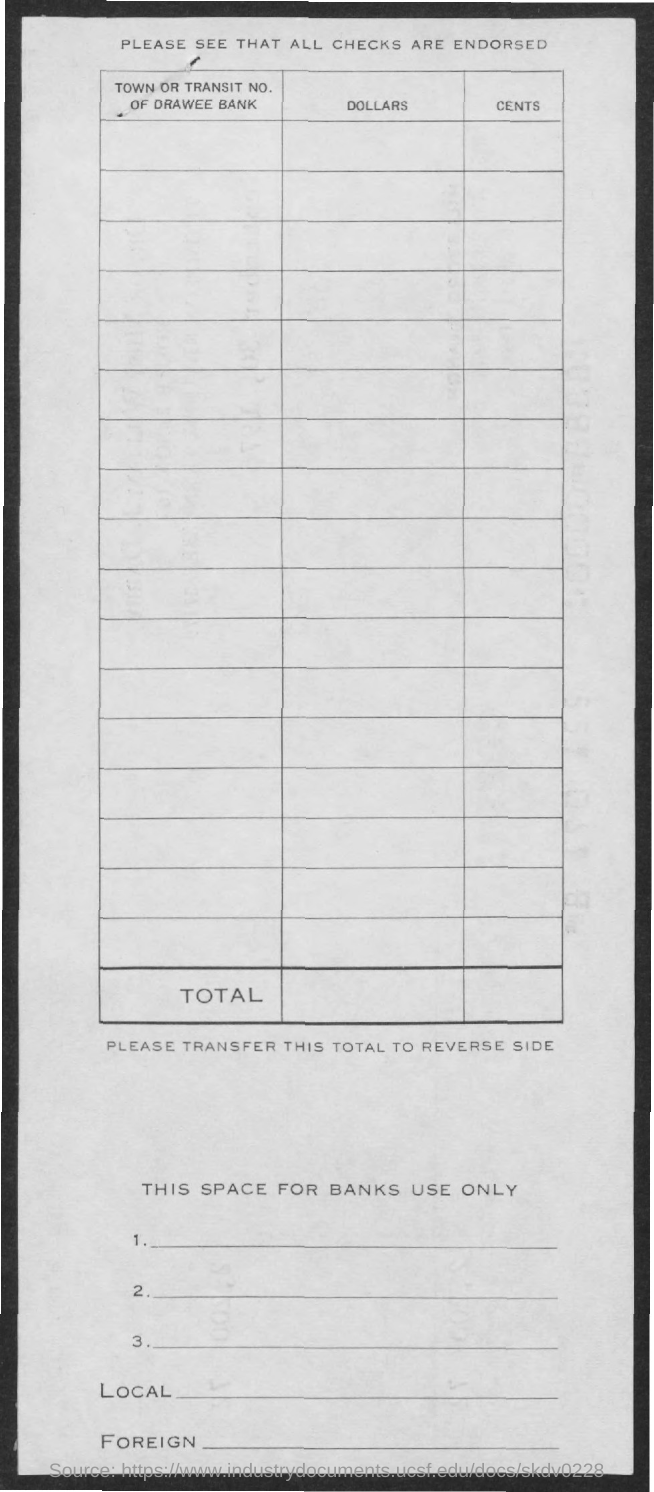Identify some key points in this picture. The title of the document is [insert title], and please ensure that all checks are endorsed [insert endorsement]. 